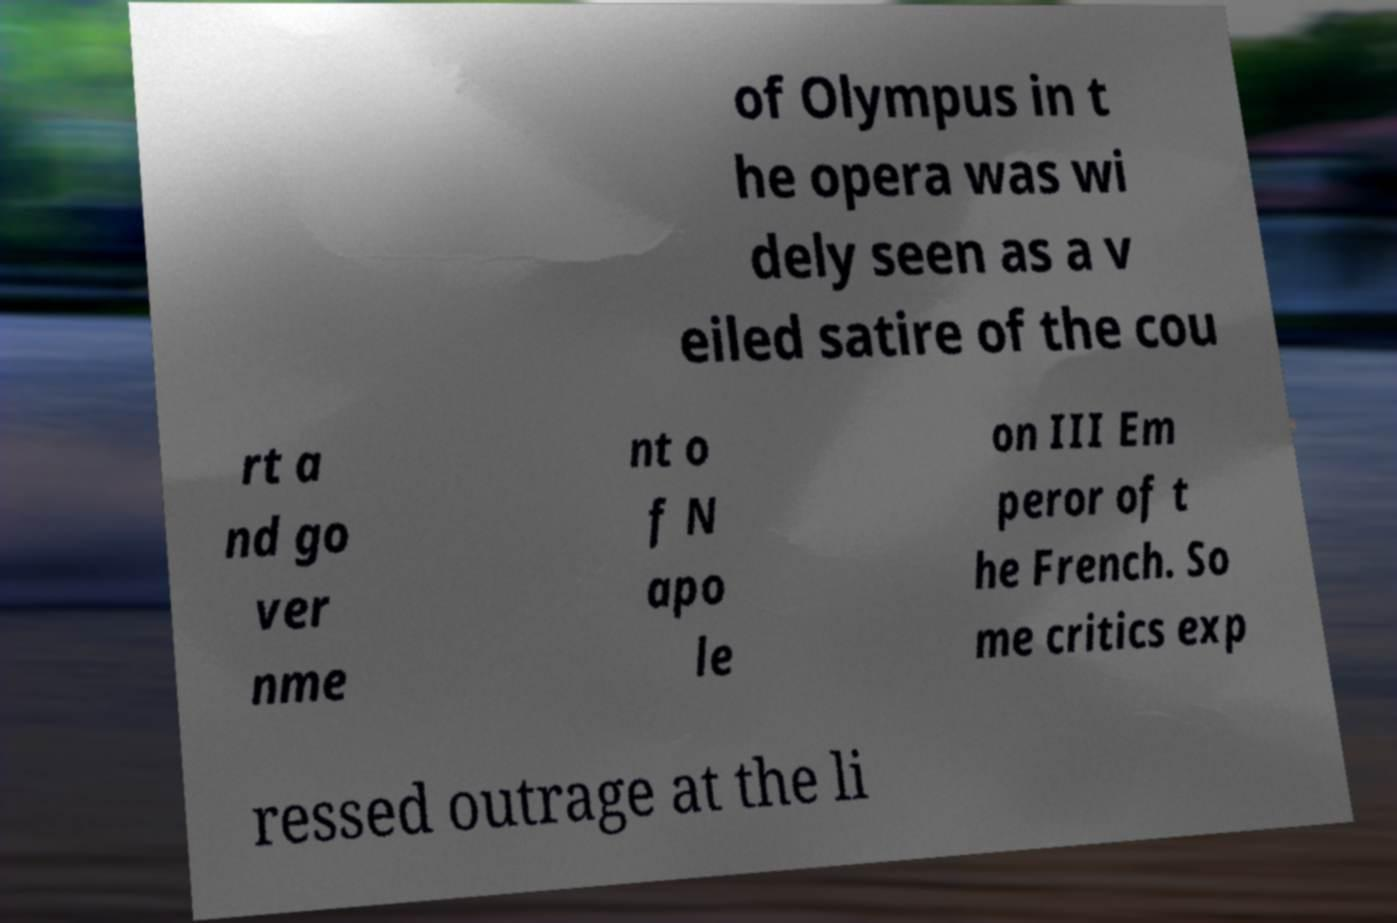Can you accurately transcribe the text from the provided image for me? of Olympus in t he opera was wi dely seen as a v eiled satire of the cou rt a nd go ver nme nt o f N apo le on III Em peror of t he French. So me critics exp ressed outrage at the li 